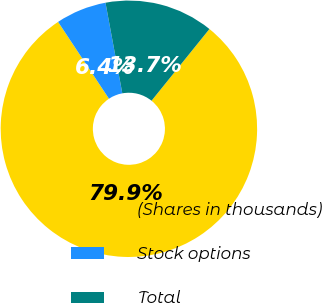Convert chart to OTSL. <chart><loc_0><loc_0><loc_500><loc_500><pie_chart><fcel>(Shares in thousands)<fcel>Stock options<fcel>Total<nl><fcel>79.88%<fcel>6.39%<fcel>13.73%<nl></chart> 